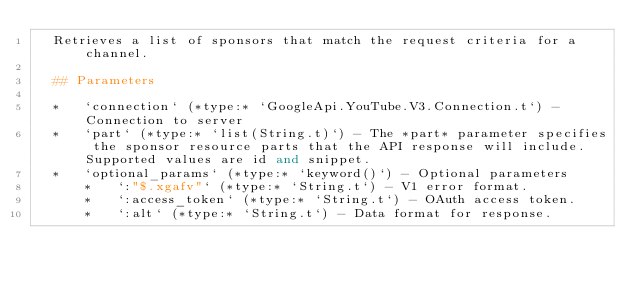<code> <loc_0><loc_0><loc_500><loc_500><_Elixir_>  Retrieves a list of sponsors that match the request criteria for a channel.

  ## Parameters

  *   `connection` (*type:* `GoogleApi.YouTube.V3.Connection.t`) - Connection to server
  *   `part` (*type:* `list(String.t)`) - The *part* parameter specifies the sponsor resource parts that the API response will include. Supported values are id and snippet.
  *   `optional_params` (*type:* `keyword()`) - Optional parameters
      *   `:"$.xgafv"` (*type:* `String.t`) - V1 error format.
      *   `:access_token` (*type:* `String.t`) - OAuth access token.
      *   `:alt` (*type:* `String.t`) - Data format for response.</code> 